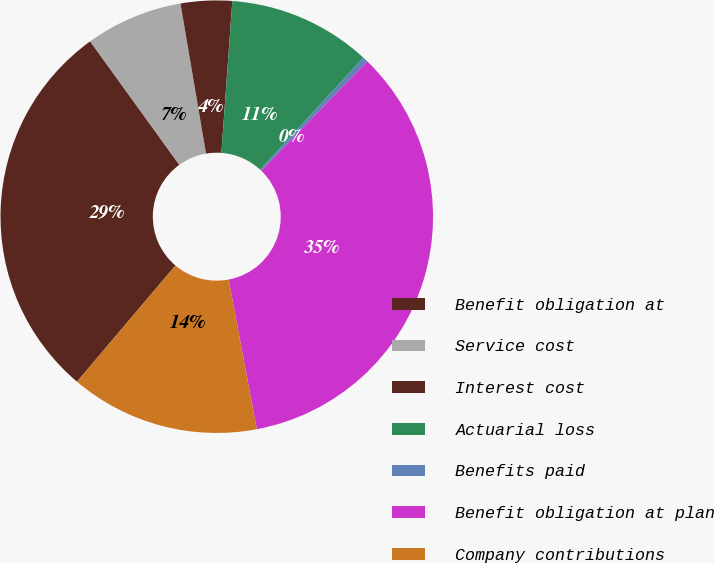Convert chart. <chart><loc_0><loc_0><loc_500><loc_500><pie_chart><fcel>Benefit obligation at<fcel>Service cost<fcel>Interest cost<fcel>Actuarial loss<fcel>Benefits paid<fcel>Benefit obligation at plan<fcel>Company contributions<nl><fcel>28.86%<fcel>7.27%<fcel>3.83%<fcel>10.71%<fcel>0.39%<fcel>34.79%<fcel>14.15%<nl></chart> 